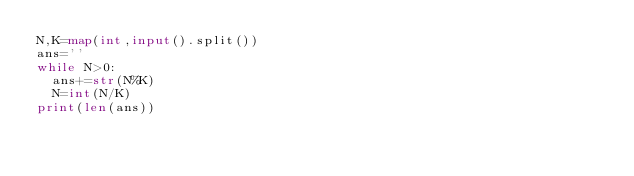Convert code to text. <code><loc_0><loc_0><loc_500><loc_500><_Python_>N,K=map(int,input().split())
ans=''
while N>0:
  ans+=str(N%K)
  N=int(N/K)
print(len(ans))
</code> 